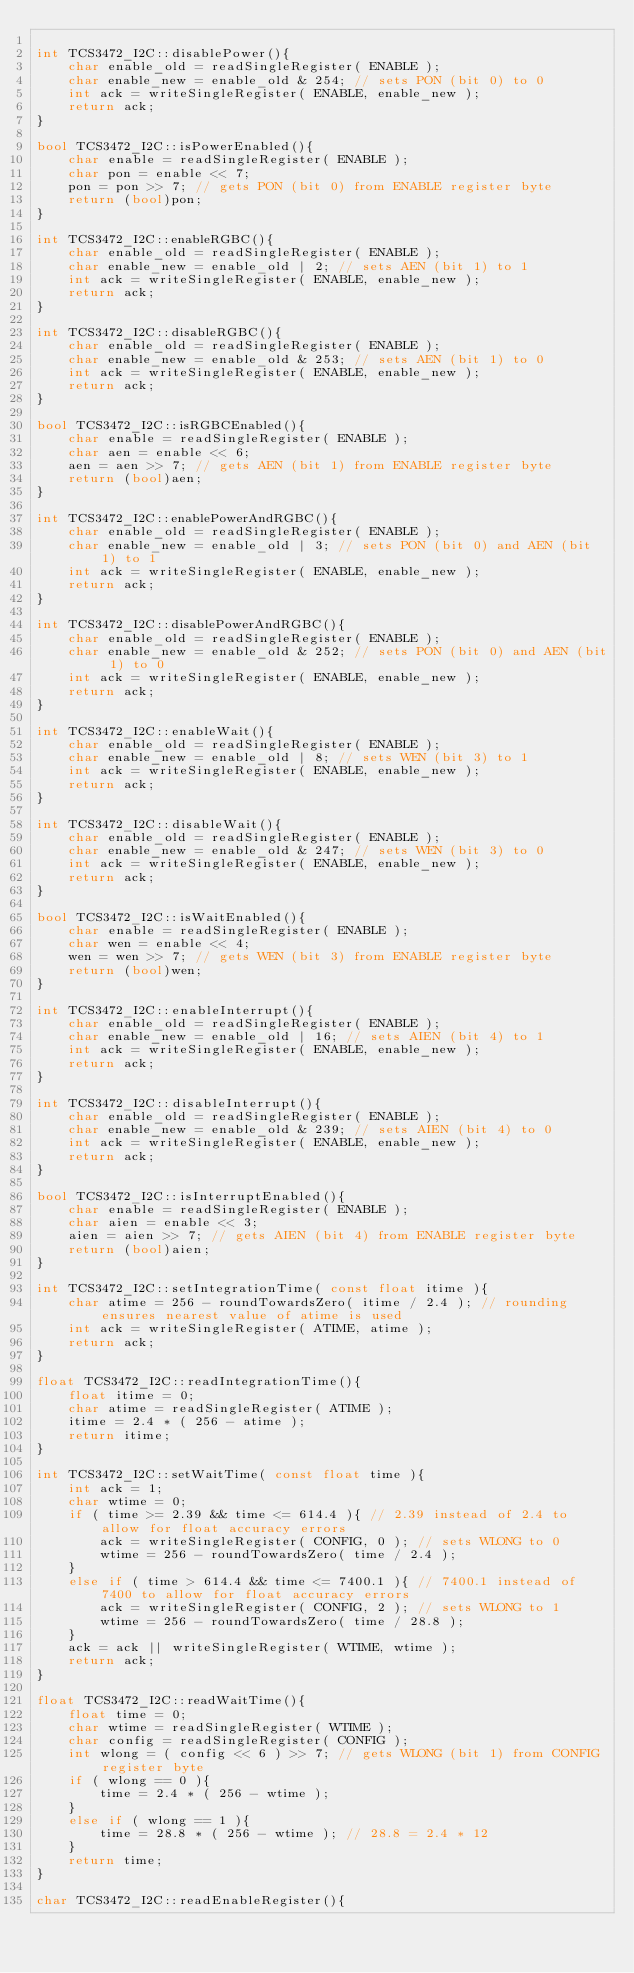<code> <loc_0><loc_0><loc_500><loc_500><_C++_> 
int TCS3472_I2C::disablePower(){
    char enable_old = readSingleRegister( ENABLE );
    char enable_new = enable_old & 254; // sets PON (bit 0) to 0
    int ack = writeSingleRegister( ENABLE, enable_new );
    return ack;
}
 
bool TCS3472_I2C::isPowerEnabled(){
    char enable = readSingleRegister( ENABLE );
    char pon = enable << 7;
    pon = pon >> 7; // gets PON (bit 0) from ENABLE register byte
    return (bool)pon;
}
 
int TCS3472_I2C::enableRGBC(){
    char enable_old = readSingleRegister( ENABLE );
    char enable_new = enable_old | 2; // sets AEN (bit 1) to 1
    int ack = writeSingleRegister( ENABLE, enable_new );
    return ack;
}
 
int TCS3472_I2C::disableRGBC(){
    char enable_old = readSingleRegister( ENABLE );
    char enable_new = enable_old & 253; // sets AEN (bit 1) to 0
    int ack = writeSingleRegister( ENABLE, enable_new );
    return ack;
}
 
bool TCS3472_I2C::isRGBCEnabled(){
    char enable = readSingleRegister( ENABLE );
    char aen = enable << 6;
    aen = aen >> 7; // gets AEN (bit 1) from ENABLE register byte
    return (bool)aen;
}
 
int TCS3472_I2C::enablePowerAndRGBC(){
    char enable_old = readSingleRegister( ENABLE );
    char enable_new = enable_old | 3; // sets PON (bit 0) and AEN (bit 1) to 1
    int ack = writeSingleRegister( ENABLE, enable_new );
    return ack;
}
 
int TCS3472_I2C::disablePowerAndRGBC(){
    char enable_old = readSingleRegister( ENABLE );
    char enable_new = enable_old & 252; // sets PON (bit 0) and AEN (bit 1) to 0
    int ack = writeSingleRegister( ENABLE, enable_new );
    return ack;
}
 
int TCS3472_I2C::enableWait(){
    char enable_old = readSingleRegister( ENABLE );
    char enable_new = enable_old | 8; // sets WEN (bit 3) to 1
    int ack = writeSingleRegister( ENABLE, enable_new );
    return ack;
}
 
int TCS3472_I2C::disableWait(){
    char enable_old = readSingleRegister( ENABLE );
    char enable_new = enable_old & 247; // sets WEN (bit 3) to 0
    int ack = writeSingleRegister( ENABLE, enable_new );
    return ack;
}
 
bool TCS3472_I2C::isWaitEnabled(){ 
    char enable = readSingleRegister( ENABLE );
    char wen = enable << 4;
    wen = wen >> 7; // gets WEN (bit 3) from ENABLE register byte
    return (bool)wen;
}
 
int TCS3472_I2C::enableInterrupt(){
    char enable_old = readSingleRegister( ENABLE );
    char enable_new = enable_old | 16; // sets AIEN (bit 4) to 1
    int ack = writeSingleRegister( ENABLE, enable_new );
    return ack;
}
 
int TCS3472_I2C::disableInterrupt(){
    char enable_old = readSingleRegister( ENABLE );
    char enable_new = enable_old & 239; // sets AIEN (bit 4) to 0
    int ack = writeSingleRegister( ENABLE, enable_new );
    return ack;
}
 
bool TCS3472_I2C::isInterruptEnabled(){
    char enable = readSingleRegister( ENABLE );
    char aien = enable << 3;
    aien = aien >> 7; // gets AIEN (bit 4) from ENABLE register byte
    return (bool)aien;
}
 
int TCS3472_I2C::setIntegrationTime( const float itime ){
    char atime = 256 - roundTowardsZero( itime / 2.4 ); // rounding ensures nearest value of atime is used
    int ack = writeSingleRegister( ATIME, atime );
    return ack;
}
 
float TCS3472_I2C::readIntegrationTime(){
    float itime = 0;
    char atime = readSingleRegister( ATIME );
    itime = 2.4 * ( 256 - atime );
    return itime;
}
 
int TCS3472_I2C::setWaitTime( const float time ){
    int ack = 1;
    char wtime = 0;
    if ( time >= 2.39 && time <= 614.4 ){ // 2.39 instead of 2.4 to allow for float accuracy errors
        ack = writeSingleRegister( CONFIG, 0 ); // sets WLONG to 0
        wtime = 256 - roundTowardsZero( time / 2.4 );
    }
    else if ( time > 614.4 && time <= 7400.1 ){ // 7400.1 instead of 7400 to allow for float accuracy errors
        ack = writeSingleRegister( CONFIG, 2 ); // sets WLONG to 1
        wtime = 256 - roundTowardsZero( time / 28.8 );
    } 
    ack = ack || writeSingleRegister( WTIME, wtime );
    return ack;
}
 
float TCS3472_I2C::readWaitTime(){
    float time = 0;
    char wtime = readSingleRegister( WTIME );
    char config = readSingleRegister( CONFIG );
    int wlong = ( config << 6 ) >> 7; // gets WLONG (bit 1) from CONFIG register byte
    if ( wlong == 0 ){
        time = 2.4 * ( 256 - wtime );
    }
    else if ( wlong == 1 ){
        time = 28.8 * ( 256 - wtime ); // 28.8 = 2.4 * 12
    }
    return time;
}
 
char TCS3472_I2C::readEnableRegister(){</code> 